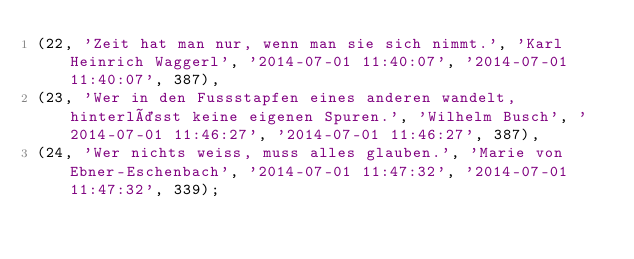Convert code to text. <code><loc_0><loc_0><loc_500><loc_500><_SQL_>(22, 'Zeit hat man nur, wenn man sie sich nimmt.', 'Karl Heinrich Waggerl', '2014-07-01 11:40:07', '2014-07-01 11:40:07', 387),
(23, 'Wer in den Fussstapfen eines anderen wandelt, hinterlässt keine eigenen Spuren.', 'Wilhelm Busch', '2014-07-01 11:46:27', '2014-07-01 11:46:27', 387),
(24, 'Wer nichts weiss, muss alles glauben.', 'Marie von Ebner-Eschenbach', '2014-07-01 11:47:32', '2014-07-01 11:47:32', 339);

</code> 